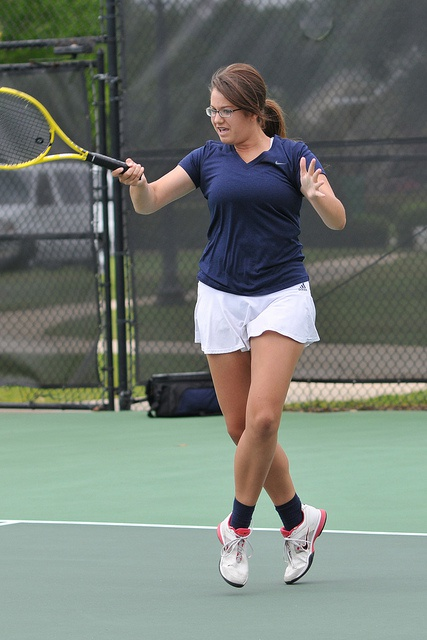Describe the objects in this image and their specific colors. I can see people in darkgreen, black, lavender, gray, and navy tones, tennis racket in darkgreen, gray, black, khaki, and gold tones, and truck in darkgreen and gray tones in this image. 